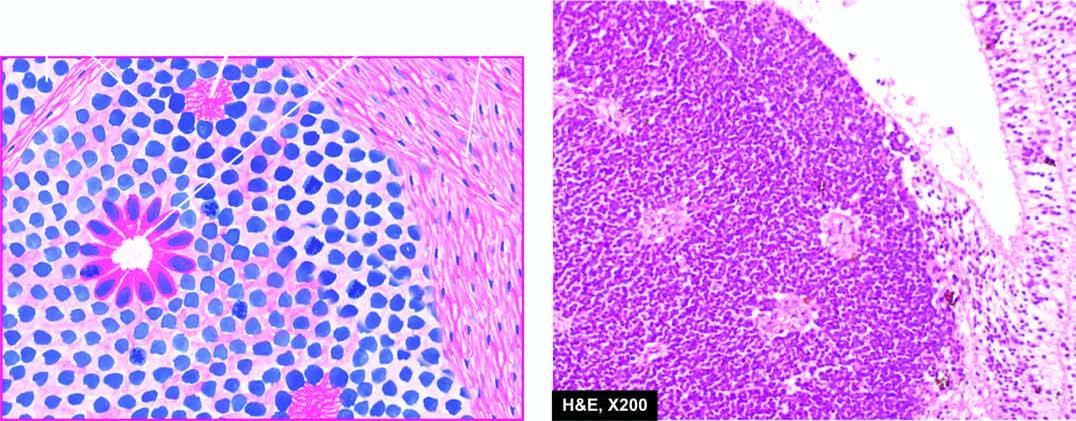does aldh show undifferentiated retinal cells and the typical rosettes?
Answer the question using a single word or phrase. No 